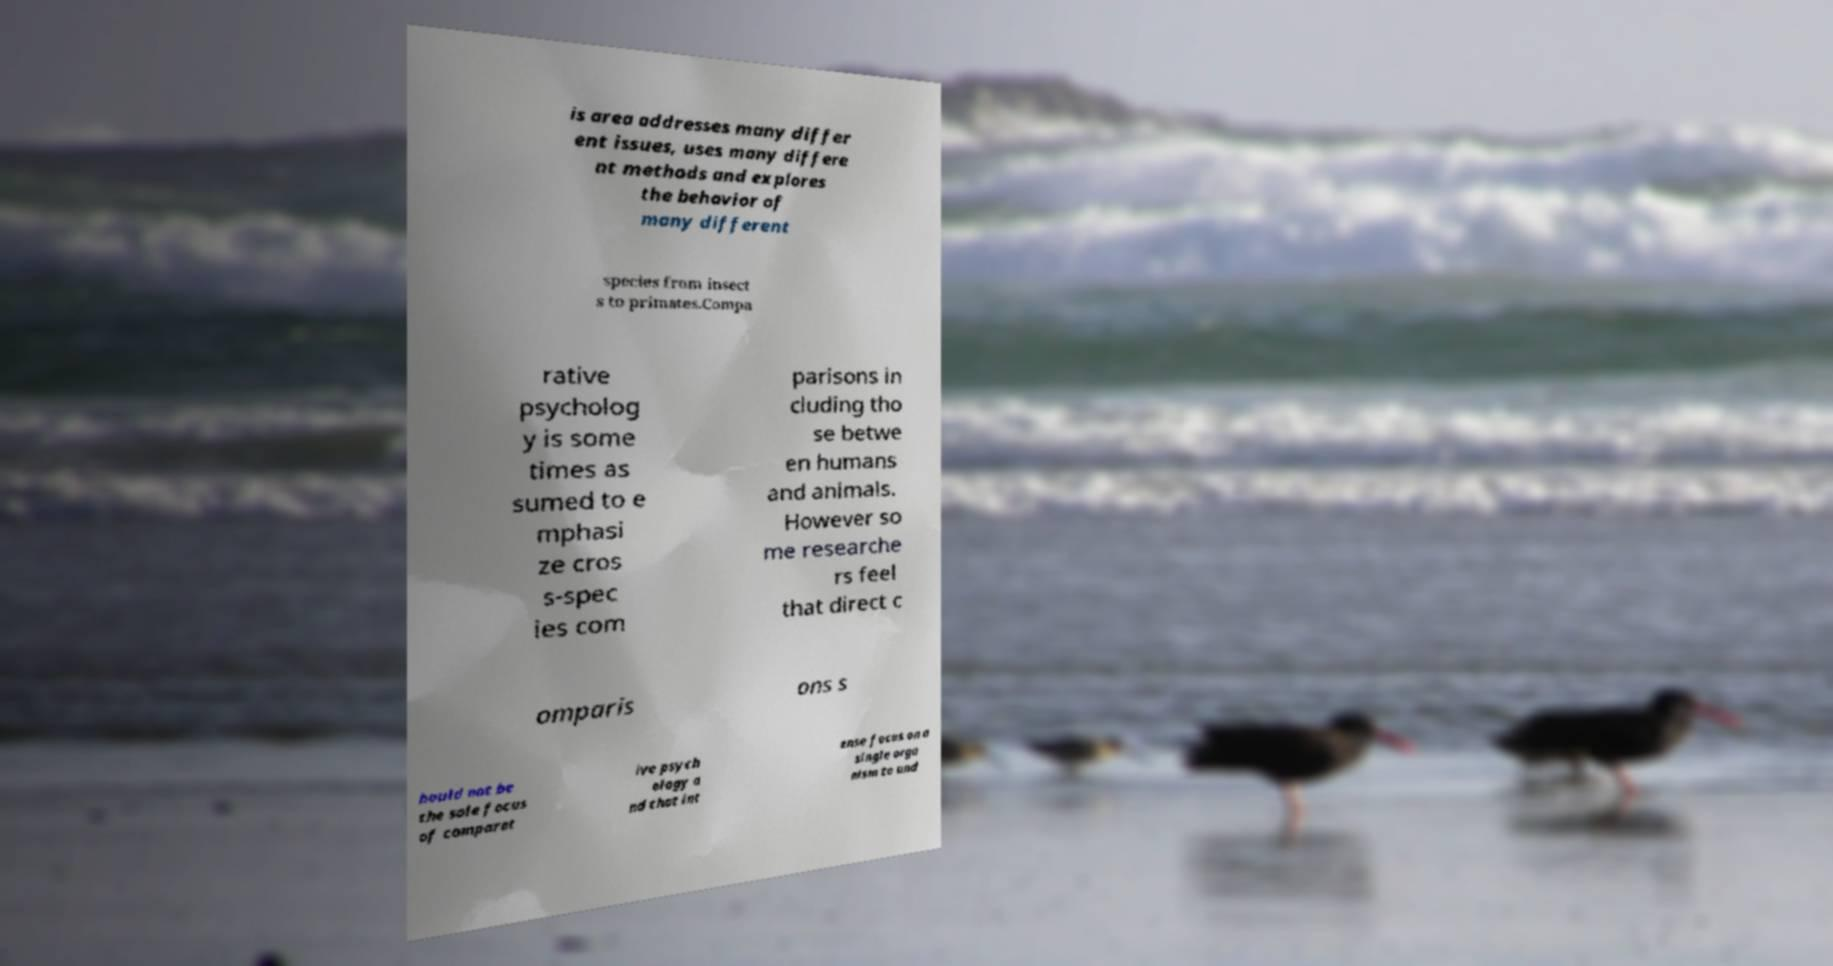Could you assist in decoding the text presented in this image and type it out clearly? is area addresses many differ ent issues, uses many differe nt methods and explores the behavior of many different species from insect s to primates.Compa rative psycholog y is some times as sumed to e mphasi ze cros s-spec ies com parisons in cluding tho se betwe en humans and animals. However so me researche rs feel that direct c omparis ons s hould not be the sole focus of comparat ive psych ology a nd that int ense focus on a single orga nism to und 